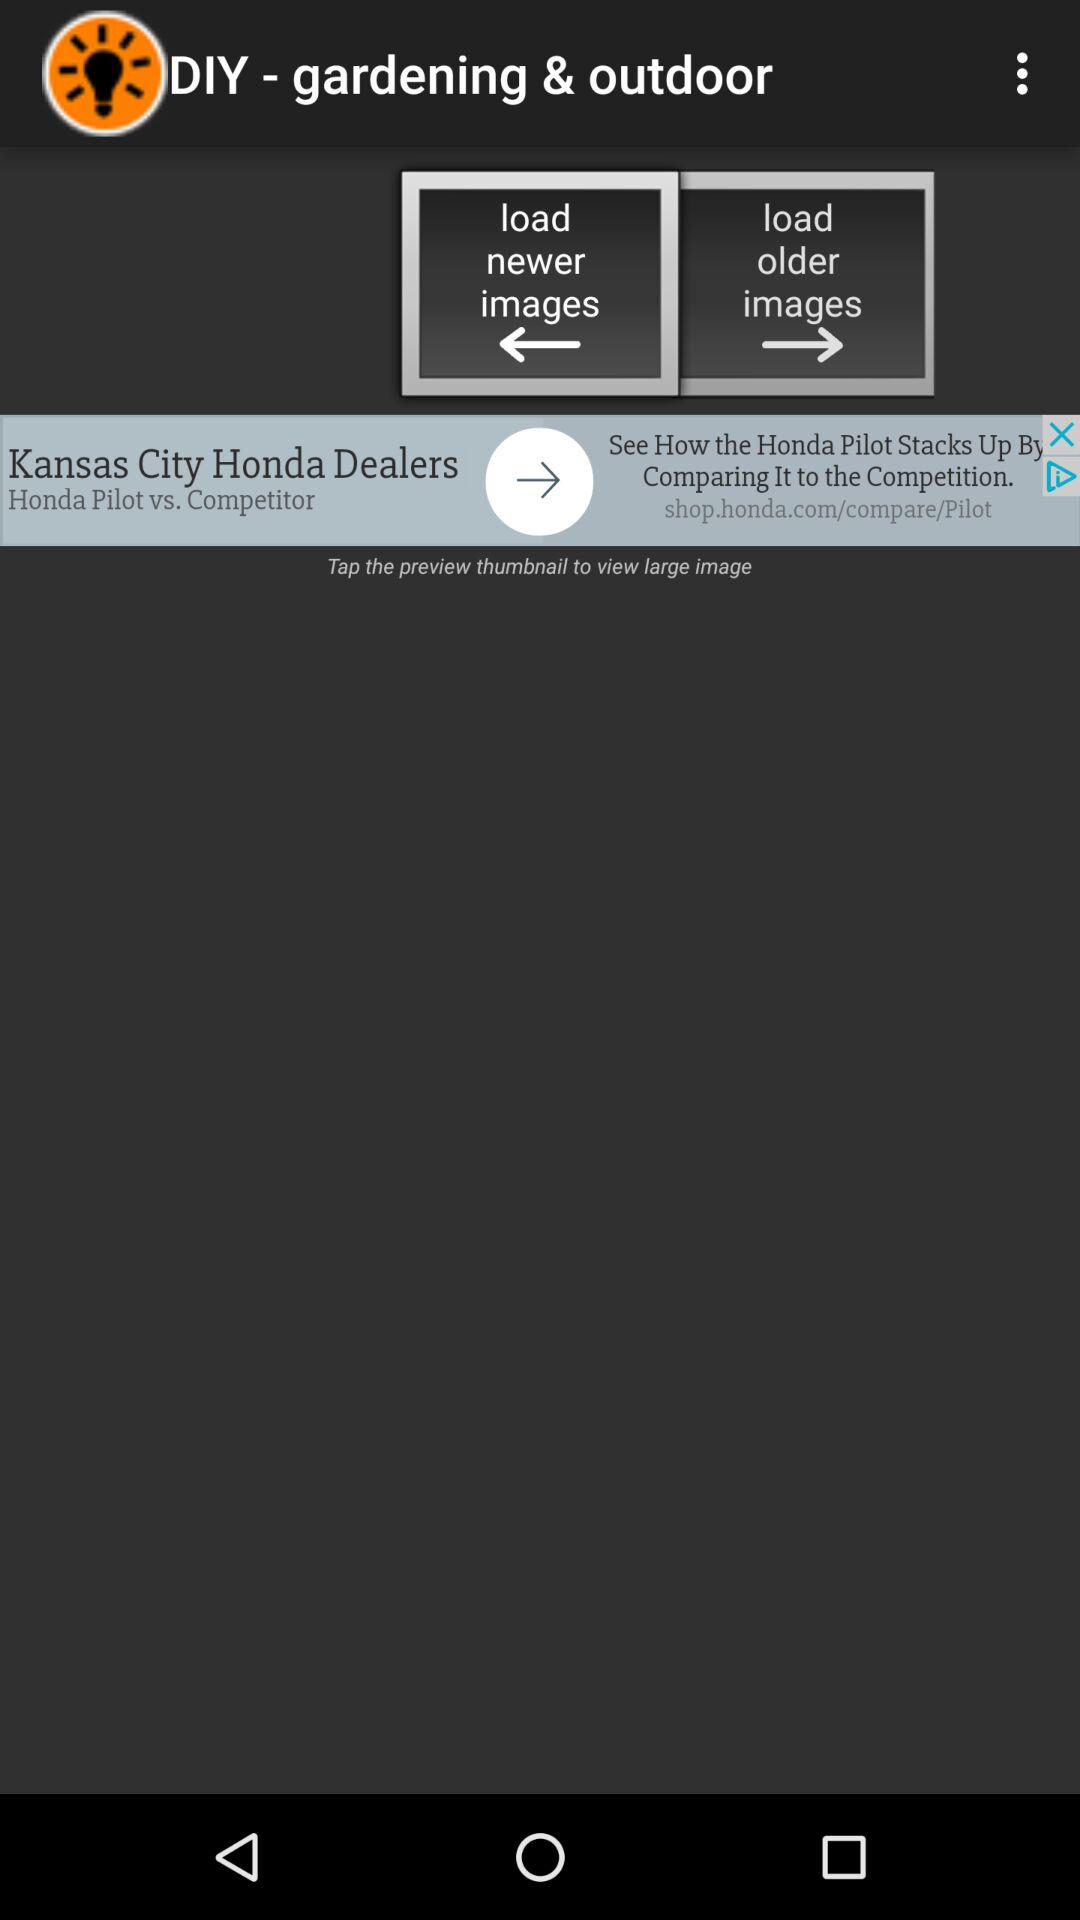What is the application name? The application name is "DIY - gardening & outdoor". 